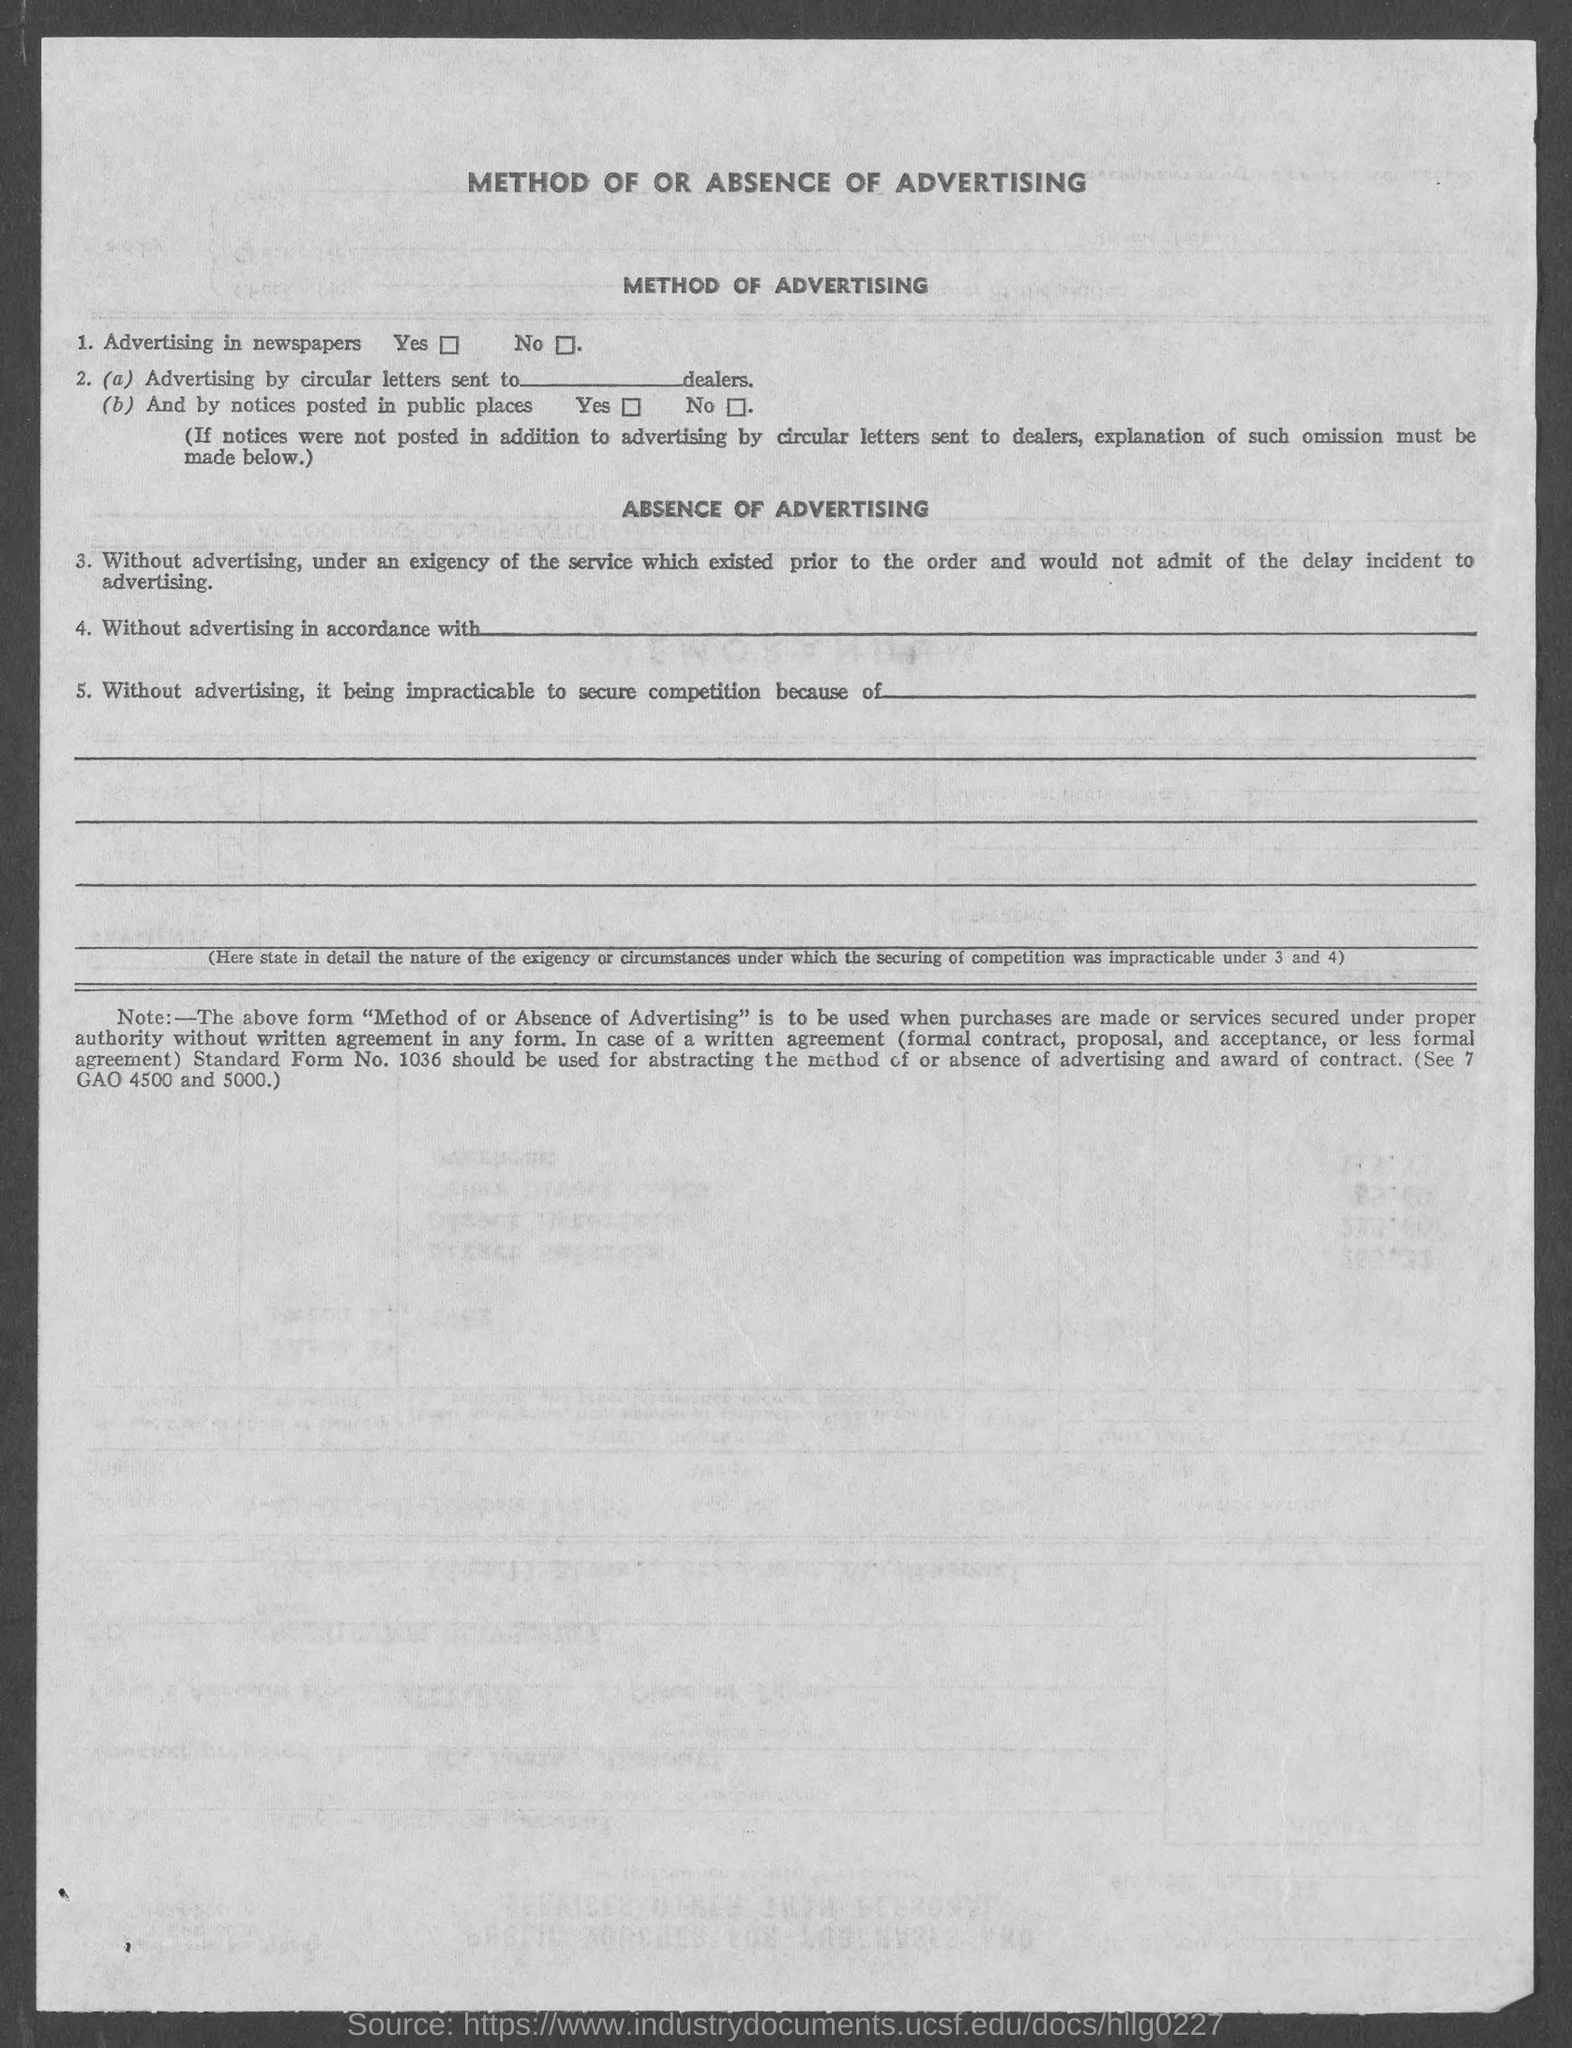List a handful of essential elements in this visual. The document title inquires into the method of or absence of advertising. 